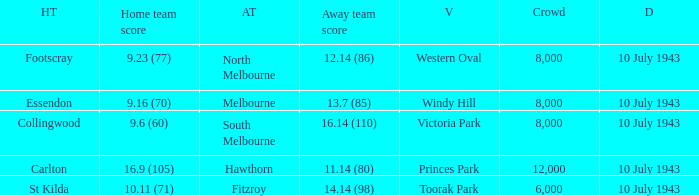When the Away team scored 14.14 (98), which Venue did the game take place? Toorak Park. 